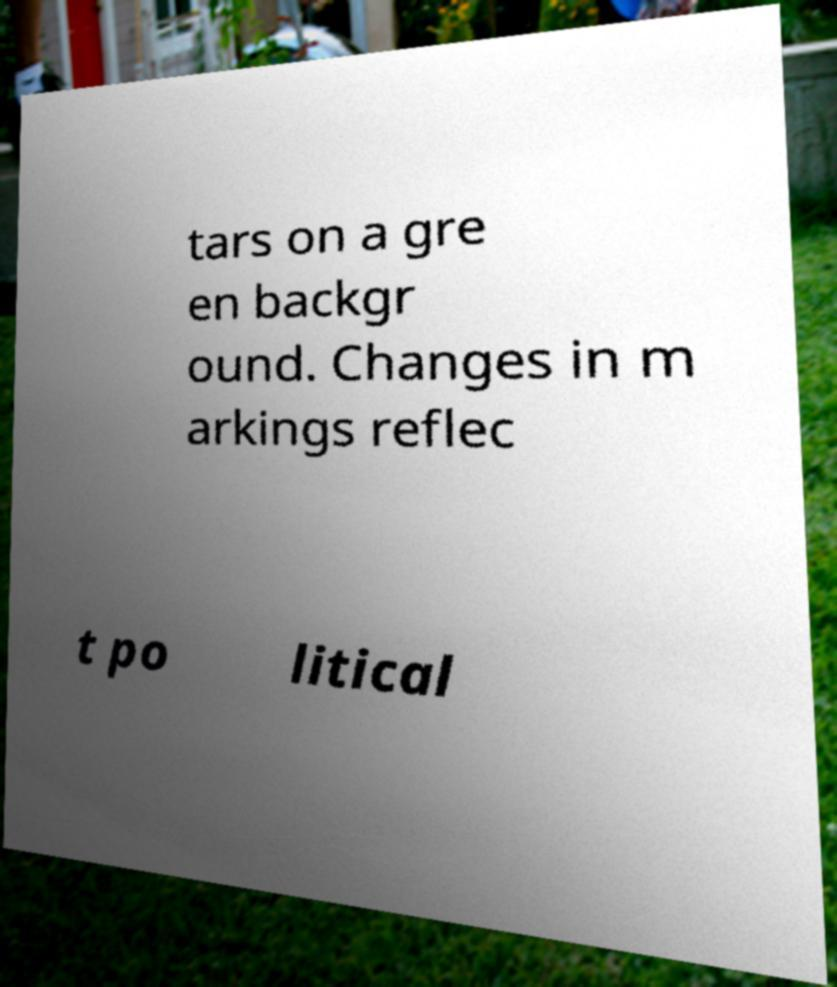What messages or text are displayed in this image? I need them in a readable, typed format. tars on a gre en backgr ound. Changes in m arkings reflec t po litical 